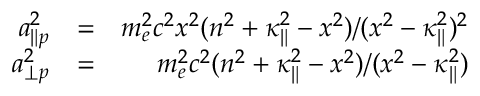<formula> <loc_0><loc_0><loc_500><loc_500>\begin{array} { r l r } { a _ { \| p } ^ { 2 } } & { = } & { m _ { e } ^ { 2 } c ^ { 2 } x ^ { 2 } ( n ^ { 2 } + \kappa _ { \| } ^ { 2 } - x ^ { 2 } ) / ( x ^ { 2 } - \kappa _ { \| } ^ { 2 } ) ^ { 2 } } \\ { a _ { \perp p } ^ { 2 } } & { = } & { m _ { e } ^ { 2 } c ^ { 2 } ( n ^ { 2 } + \kappa _ { \| } ^ { 2 } - x ^ { 2 } ) / ( x ^ { 2 } - \kappa _ { \| } ^ { 2 } ) } \end{array}</formula> 